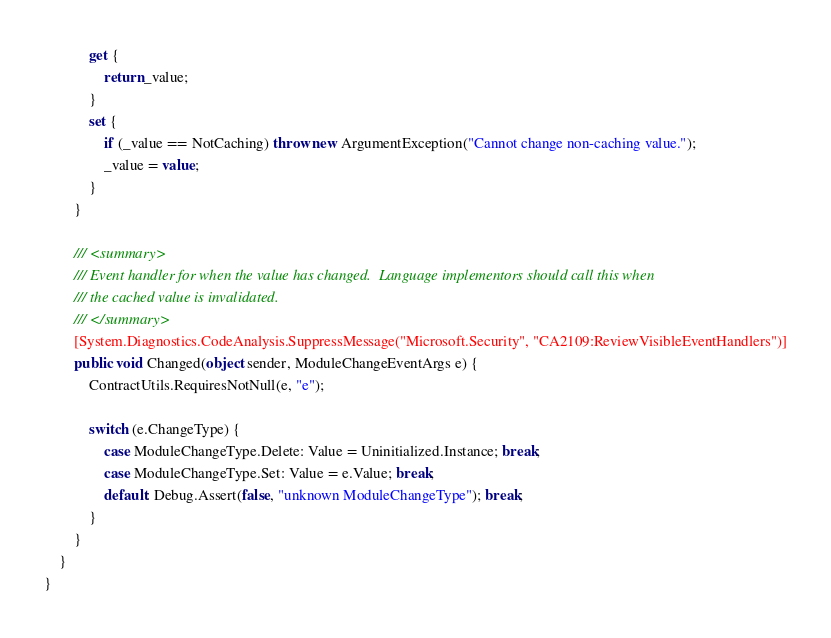<code> <loc_0><loc_0><loc_500><loc_500><_C#_>            get {
                return _value;
            }
            set {
                if (_value == NotCaching) throw new ArgumentException("Cannot change non-caching value.");
                _value = value;
            }
        }

        /// <summary>
        /// Event handler for when the value has changed.  Language implementors should call this when
        /// the cached value is invalidated.
        /// </summary>
        [System.Diagnostics.CodeAnalysis.SuppressMessage("Microsoft.Security", "CA2109:ReviewVisibleEventHandlers")]
        public void Changed(object sender, ModuleChangeEventArgs e) {
            ContractUtils.RequiresNotNull(e, "e");

            switch (e.ChangeType) {
                case ModuleChangeType.Delete: Value = Uninitialized.Instance; break;
                case ModuleChangeType.Set: Value = e.Value; break;
                default: Debug.Assert(false, "unknown ModuleChangeType"); break;
            }
        }
    }
}
</code> 